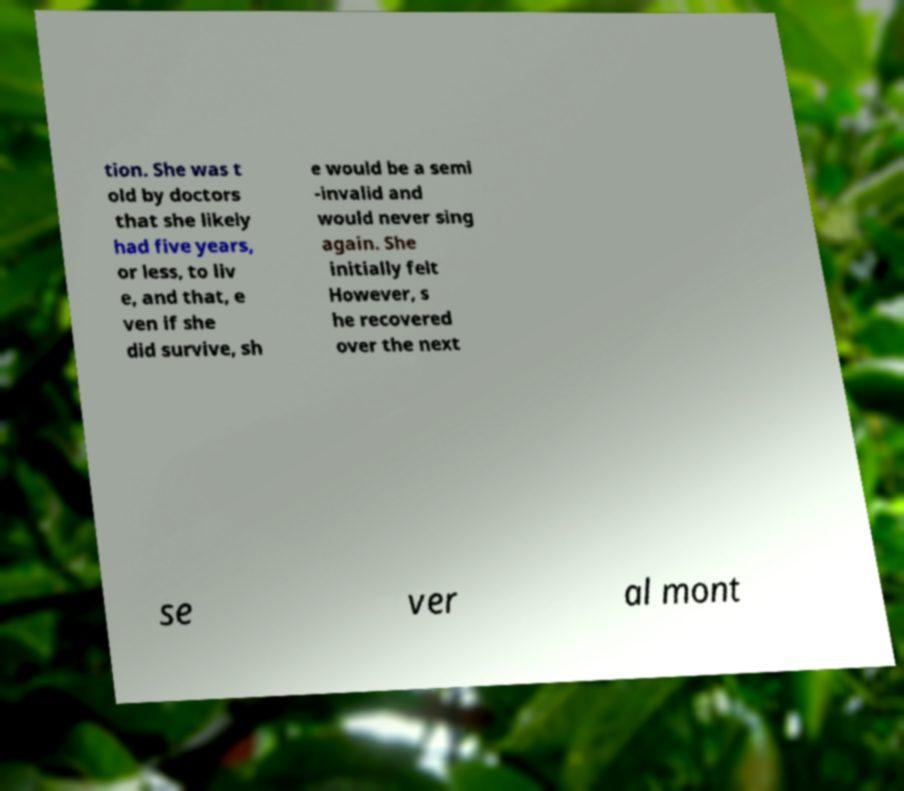I need the written content from this picture converted into text. Can you do that? tion. She was t old by doctors that she likely had five years, or less, to liv e, and that, e ven if she did survive, sh e would be a semi -invalid and would never sing again. She initially felt However, s he recovered over the next se ver al mont 